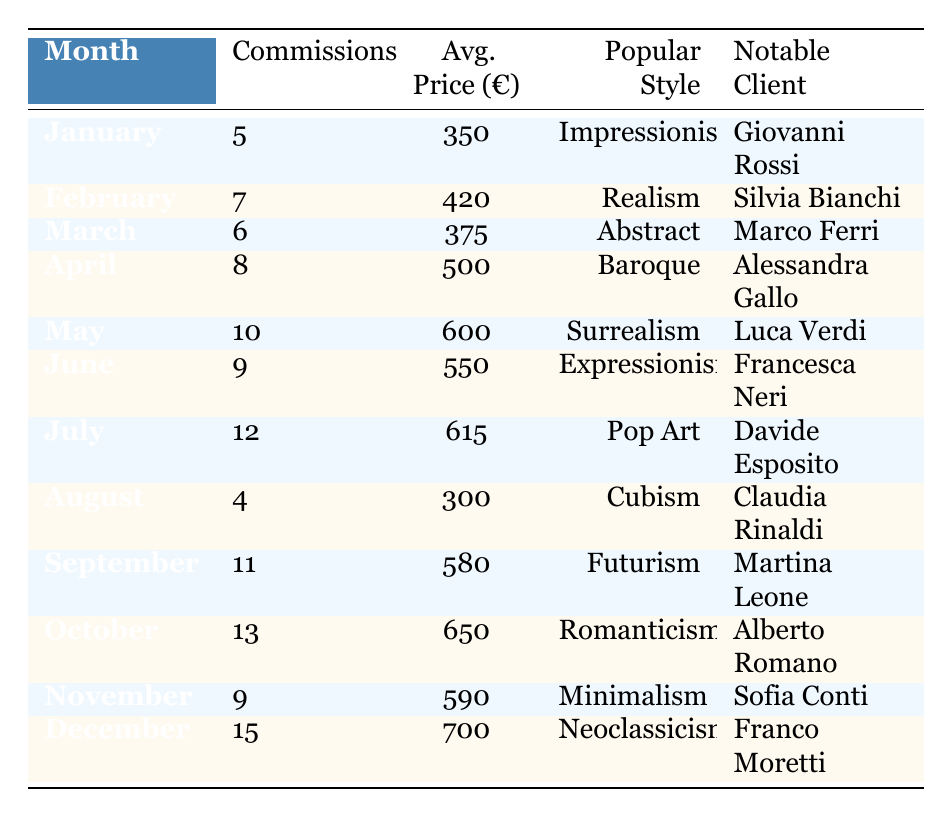What was the most popular style of artwork commissioned in December 2023? The table indicates that the most popular style of artwork commissioned in December 2023 is Neoclassicism.
Answer: Neoclassicism How many commissions were there in July 2023? According to the table, there were 12 commissions made in July 2023.
Answer: 12 What is the average price of commissions in May 2023? The table shows that the average price of commissions in May 2023 was €600.
Answer: €600 Which month had the highest number of commissions? By examining the table, December 2023 had the highest number of commissions, which was 15.
Answer: December 2023 What is the total number of commissions from January to March 2023? To find the total, we add the number of commissions for January (5), February (7), and March (6): 5 + 7 + 6 = 18.
Answer: 18 Was the average price of commissioned artworks higher in October 2023 compared to September 2023? The average price in October 2023 was €650, while in September 2023 it was €580. Since €650 is greater than €580, the statement is true.
Answer: Yes What was the notable client in April 2023? The table states that the notable client in April 2023 was Alessandra Gallo.
Answer: Alessandra Gallo Determine the change in average price from August to September 2023. The average price in August 2023 was €300 and in September 2023 it was €580. The change is €580 - €300 = €280.
Answer: €280 Which month saw a greater average price, February or June? February's average price was €420, and June's was €550. Since €550 is greater than €420, June had a greater average price.
Answer: June What are the total commissions and average price for the months of November and December 2023? November had 9 commissions at an average price of €590, and December had 15 commissions at €700. The total commissions are 9 + 15 = 24, and the average is calculated as (590 + 700) / 2 = 645.
Answer: Total: 24, Average: €645 